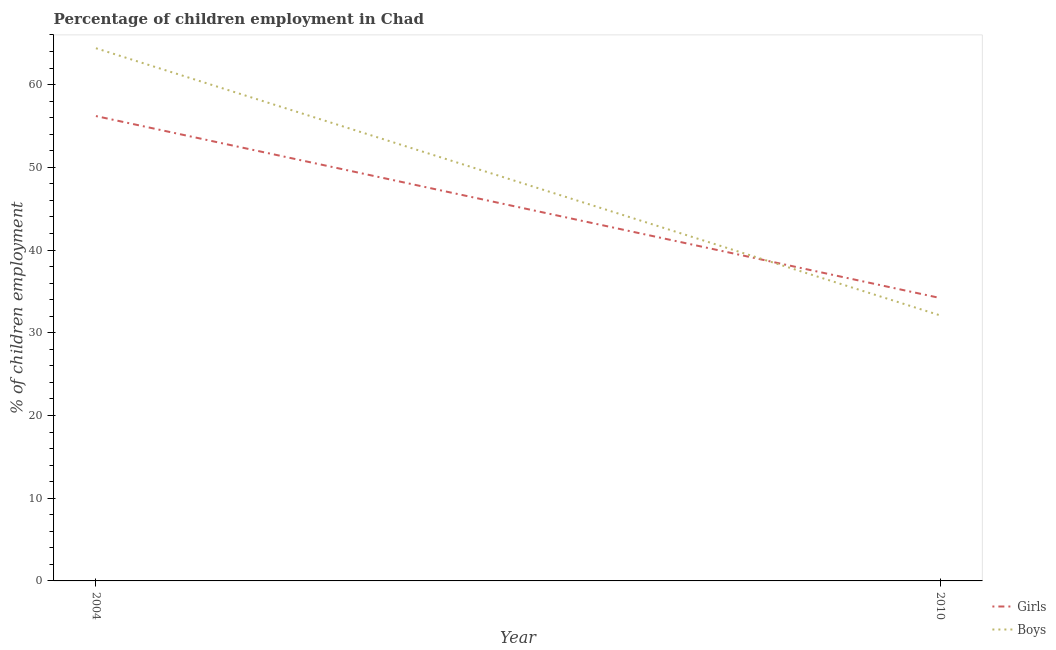Does the line corresponding to percentage of employed boys intersect with the line corresponding to percentage of employed girls?
Keep it short and to the point. Yes. Is the number of lines equal to the number of legend labels?
Your response must be concise. Yes. What is the percentage of employed boys in 2010?
Give a very brief answer. 32.1. Across all years, what is the maximum percentage of employed boys?
Offer a terse response. 64.4. Across all years, what is the minimum percentage of employed girls?
Ensure brevity in your answer.  34.2. In which year was the percentage of employed boys maximum?
Ensure brevity in your answer.  2004. In which year was the percentage of employed boys minimum?
Make the answer very short. 2010. What is the total percentage of employed girls in the graph?
Offer a terse response. 90.4. What is the difference between the percentage of employed boys in 2004 and that in 2010?
Provide a succinct answer. 32.3. What is the difference between the percentage of employed boys in 2004 and the percentage of employed girls in 2010?
Offer a terse response. 30.2. What is the average percentage of employed girls per year?
Provide a short and direct response. 45.2. In the year 2010, what is the difference between the percentage of employed girls and percentage of employed boys?
Provide a short and direct response. 2.1. What is the ratio of the percentage of employed girls in 2004 to that in 2010?
Offer a very short reply. 1.64. In how many years, is the percentage of employed boys greater than the average percentage of employed boys taken over all years?
Provide a short and direct response. 1. Is the percentage of employed boys strictly greater than the percentage of employed girls over the years?
Provide a succinct answer. No. How many years are there in the graph?
Ensure brevity in your answer.  2. Does the graph contain any zero values?
Offer a very short reply. No. How are the legend labels stacked?
Make the answer very short. Vertical. What is the title of the graph?
Provide a short and direct response. Percentage of children employment in Chad. Does "Resident workers" appear as one of the legend labels in the graph?
Keep it short and to the point. No. What is the label or title of the X-axis?
Keep it short and to the point. Year. What is the label or title of the Y-axis?
Your answer should be compact. % of children employment. What is the % of children employment of Girls in 2004?
Offer a very short reply. 56.2. What is the % of children employment in Boys in 2004?
Your response must be concise. 64.4. What is the % of children employment of Girls in 2010?
Your answer should be very brief. 34.2. What is the % of children employment in Boys in 2010?
Give a very brief answer. 32.1. Across all years, what is the maximum % of children employment in Girls?
Your answer should be very brief. 56.2. Across all years, what is the maximum % of children employment of Boys?
Your answer should be compact. 64.4. Across all years, what is the minimum % of children employment in Girls?
Keep it short and to the point. 34.2. Across all years, what is the minimum % of children employment of Boys?
Provide a succinct answer. 32.1. What is the total % of children employment in Girls in the graph?
Give a very brief answer. 90.4. What is the total % of children employment in Boys in the graph?
Offer a very short reply. 96.5. What is the difference between the % of children employment of Girls in 2004 and that in 2010?
Offer a very short reply. 22. What is the difference between the % of children employment of Boys in 2004 and that in 2010?
Keep it short and to the point. 32.3. What is the difference between the % of children employment of Girls in 2004 and the % of children employment of Boys in 2010?
Ensure brevity in your answer.  24.1. What is the average % of children employment in Girls per year?
Your answer should be compact. 45.2. What is the average % of children employment of Boys per year?
Your answer should be compact. 48.25. What is the ratio of the % of children employment of Girls in 2004 to that in 2010?
Provide a short and direct response. 1.64. What is the ratio of the % of children employment of Boys in 2004 to that in 2010?
Ensure brevity in your answer.  2.01. What is the difference between the highest and the second highest % of children employment in Boys?
Your answer should be compact. 32.3. What is the difference between the highest and the lowest % of children employment in Boys?
Your answer should be compact. 32.3. 